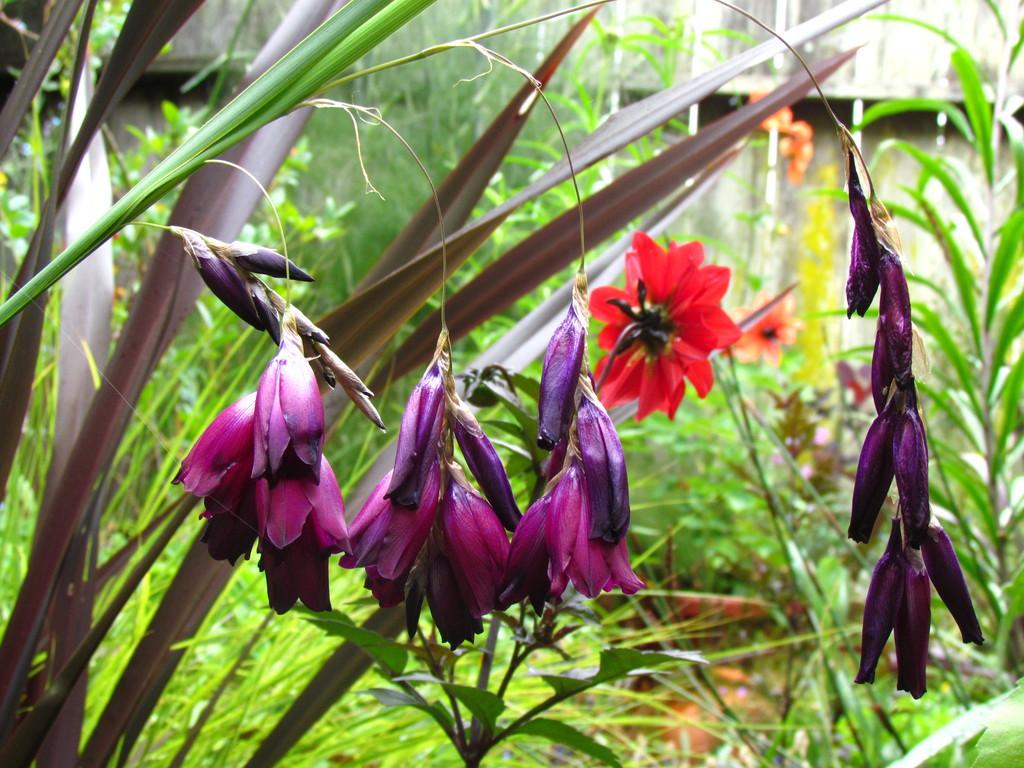What is the main subject of the image? The main subject of the image is the many plants. Can you describe the flowers in the center of the image? Yes, there are red and purple color flowers in the center of the image. What can be seen in the background of the image? There is a building in the background of the image. How many boats are visible in the image? There are no boats present in the image. What type of trail can be seen in the image? There is no trail visible in the image. 